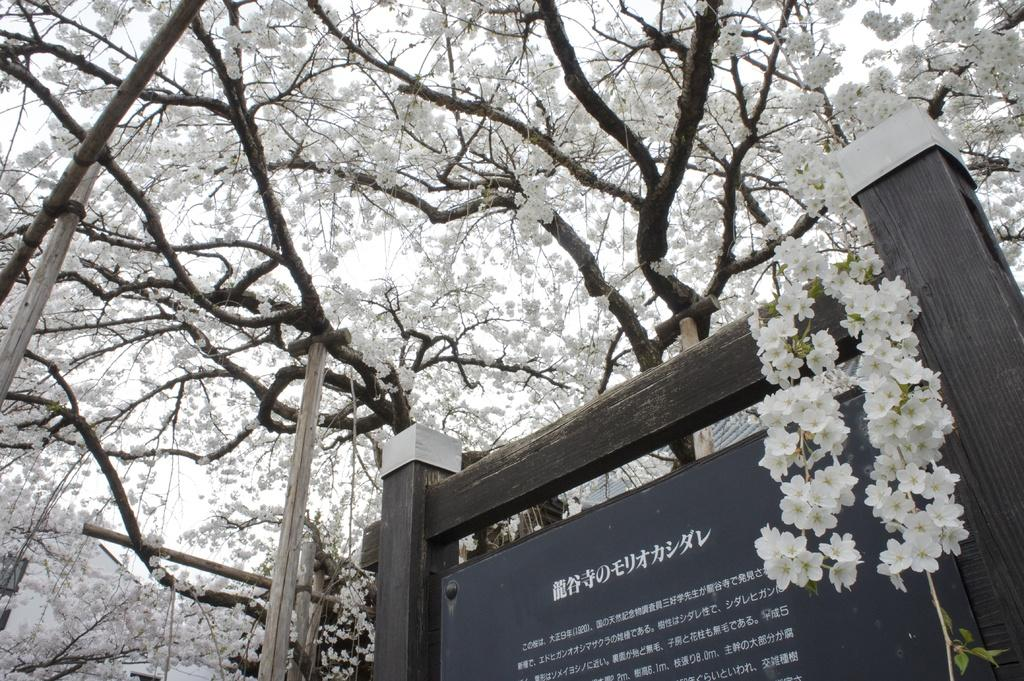What is the main object in the center of the image? There is a board in the center of the image. What can be seen on the board? There is text and flowers on the board. What is visible in the background of the image? The sky, clouds, trees, and flowers are visible in the background of the image. What type of army is depicted in the image? There is no army present in the image; it features a board with text and flowers. What belief system is represented by the flowers in the image? The image does not represent any specific belief system; it simply contains a board with text and flowers. 